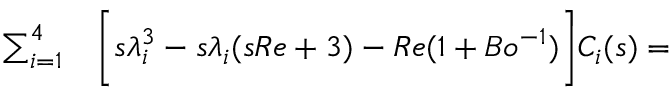<formula> <loc_0><loc_0><loc_500><loc_500>\begin{array} { r l } { \sum _ { i = 1 } ^ { 4 } } & \left [ s \lambda _ { i } ^ { 3 } - s \lambda _ { i } ( s R e + 3 ) - R e ( 1 + B o ^ { - 1 } ) \right ] C _ { i } ( s ) = } \end{array}</formula> 